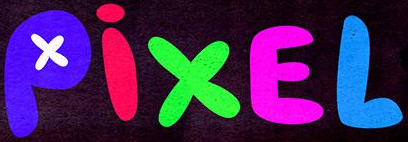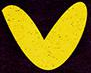What text is displayed in these images sequentially, separated by a semicolon? PixEL; v 